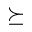<formula> <loc_0><loc_0><loc_500><loc_500>\succeq</formula> 